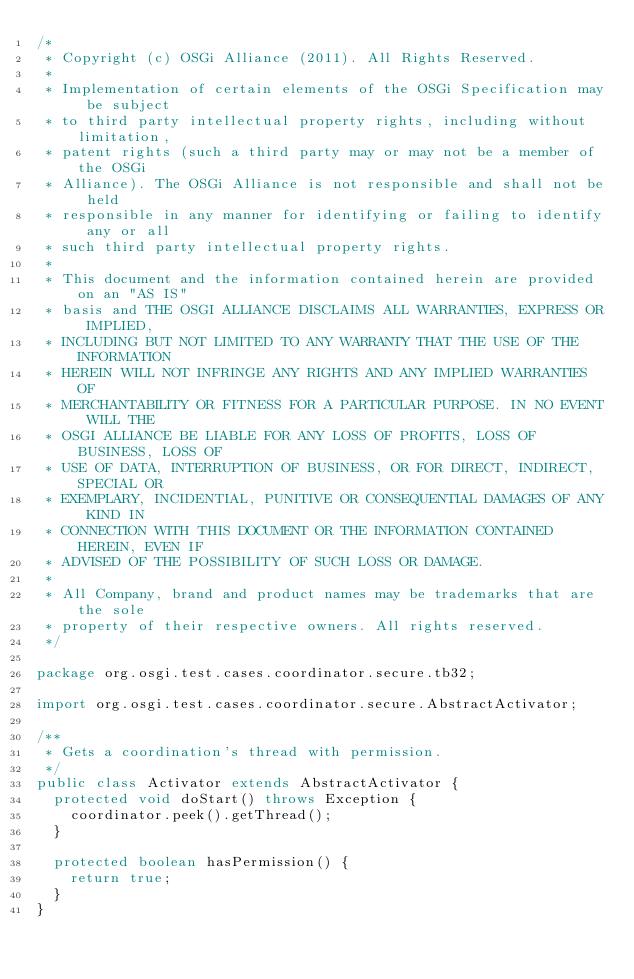Convert code to text. <code><loc_0><loc_0><loc_500><loc_500><_Java_>/*
 * Copyright (c) OSGi Alliance (2011). All Rights Reserved.
 * 
 * Implementation of certain elements of the OSGi Specification may be subject
 * to third party intellectual property rights, including without limitation,
 * patent rights (such a third party may or may not be a member of the OSGi
 * Alliance). The OSGi Alliance is not responsible and shall not be held
 * responsible in any manner for identifying or failing to identify any or all
 * such third party intellectual property rights.
 * 
 * This document and the information contained herein are provided on an "AS IS"
 * basis and THE OSGI ALLIANCE DISCLAIMS ALL WARRANTIES, EXPRESS OR IMPLIED,
 * INCLUDING BUT NOT LIMITED TO ANY WARRANTY THAT THE USE OF THE INFORMATION
 * HEREIN WILL NOT INFRINGE ANY RIGHTS AND ANY IMPLIED WARRANTIES OF
 * MERCHANTABILITY OR FITNESS FOR A PARTICULAR PURPOSE. IN NO EVENT WILL THE
 * OSGI ALLIANCE BE LIABLE FOR ANY LOSS OF PROFITS, LOSS OF BUSINESS, LOSS OF
 * USE OF DATA, INTERRUPTION OF BUSINESS, OR FOR DIRECT, INDIRECT, SPECIAL OR
 * EXEMPLARY, INCIDENTIAL, PUNITIVE OR CONSEQUENTIAL DAMAGES OF ANY KIND IN
 * CONNECTION WITH THIS DOCUMENT OR THE INFORMATION CONTAINED HEREIN, EVEN IF
 * ADVISED OF THE POSSIBILITY OF SUCH LOSS OR DAMAGE.
 * 
 * All Company, brand and product names may be trademarks that are the sole
 * property of their respective owners. All rights reserved.
 */

package org.osgi.test.cases.coordinator.secure.tb32;

import org.osgi.test.cases.coordinator.secure.AbstractActivator;

/**
 * Gets a coordination's thread with permission.
 */
public class Activator extends AbstractActivator {
	protected void doStart() throws Exception {
		coordinator.peek().getThread();
	}
	
	protected boolean hasPermission() {
		return true;
	}
}
</code> 